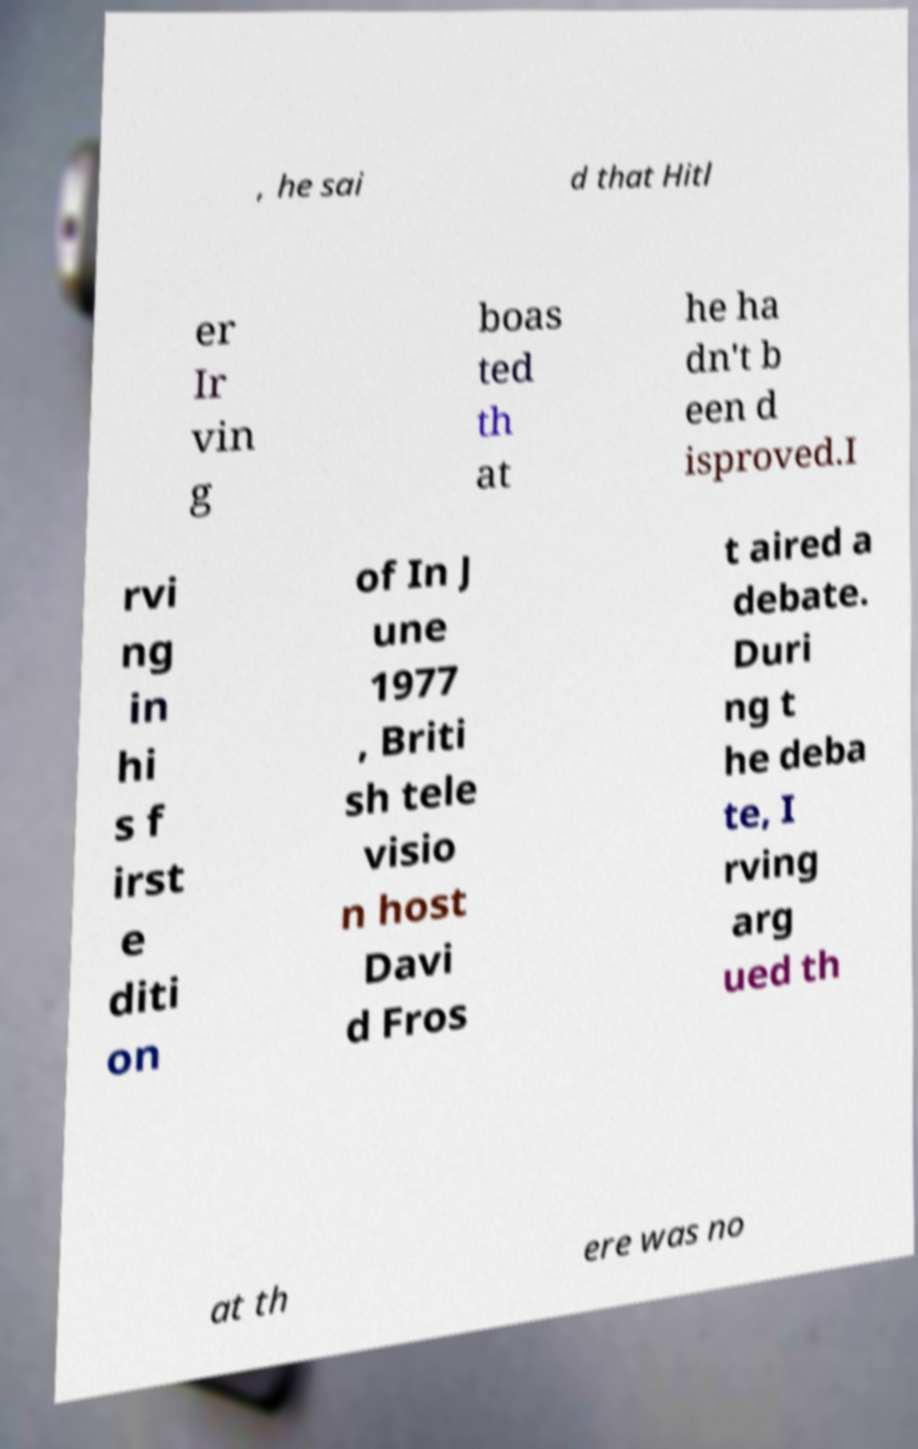Please identify and transcribe the text found in this image. , he sai d that Hitl er Ir vin g boas ted th at he ha dn't b een d isproved.I rvi ng in hi s f irst e diti on of In J une 1977 , Briti sh tele visio n host Davi d Fros t aired a debate. Duri ng t he deba te, I rving arg ued th at th ere was no 